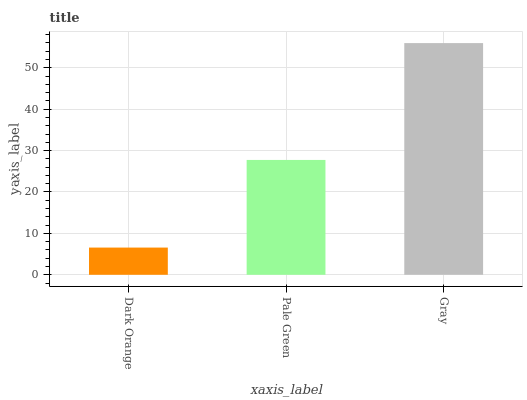Is Dark Orange the minimum?
Answer yes or no. Yes. Is Gray the maximum?
Answer yes or no. Yes. Is Pale Green the minimum?
Answer yes or no. No. Is Pale Green the maximum?
Answer yes or no. No. Is Pale Green greater than Dark Orange?
Answer yes or no. Yes. Is Dark Orange less than Pale Green?
Answer yes or no. Yes. Is Dark Orange greater than Pale Green?
Answer yes or no. No. Is Pale Green less than Dark Orange?
Answer yes or no. No. Is Pale Green the high median?
Answer yes or no. Yes. Is Pale Green the low median?
Answer yes or no. Yes. Is Gray the high median?
Answer yes or no. No. Is Dark Orange the low median?
Answer yes or no. No. 